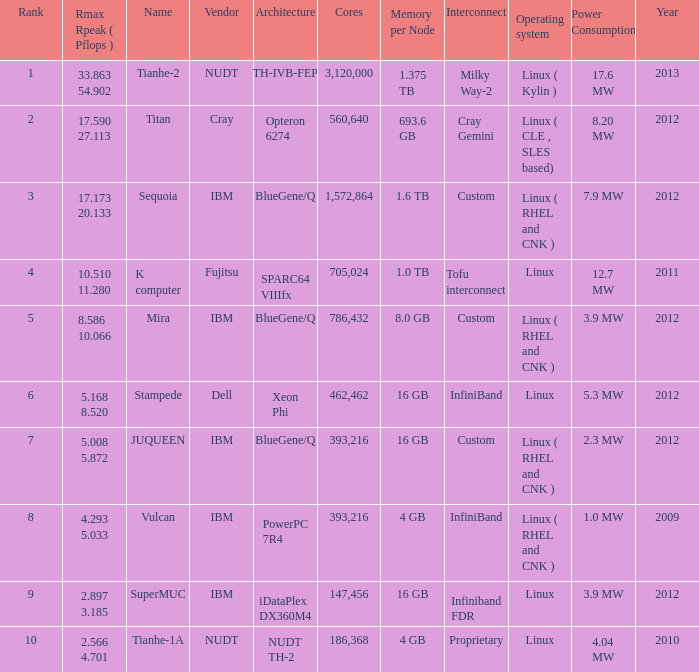What is the name of Rank 5? Mira. 